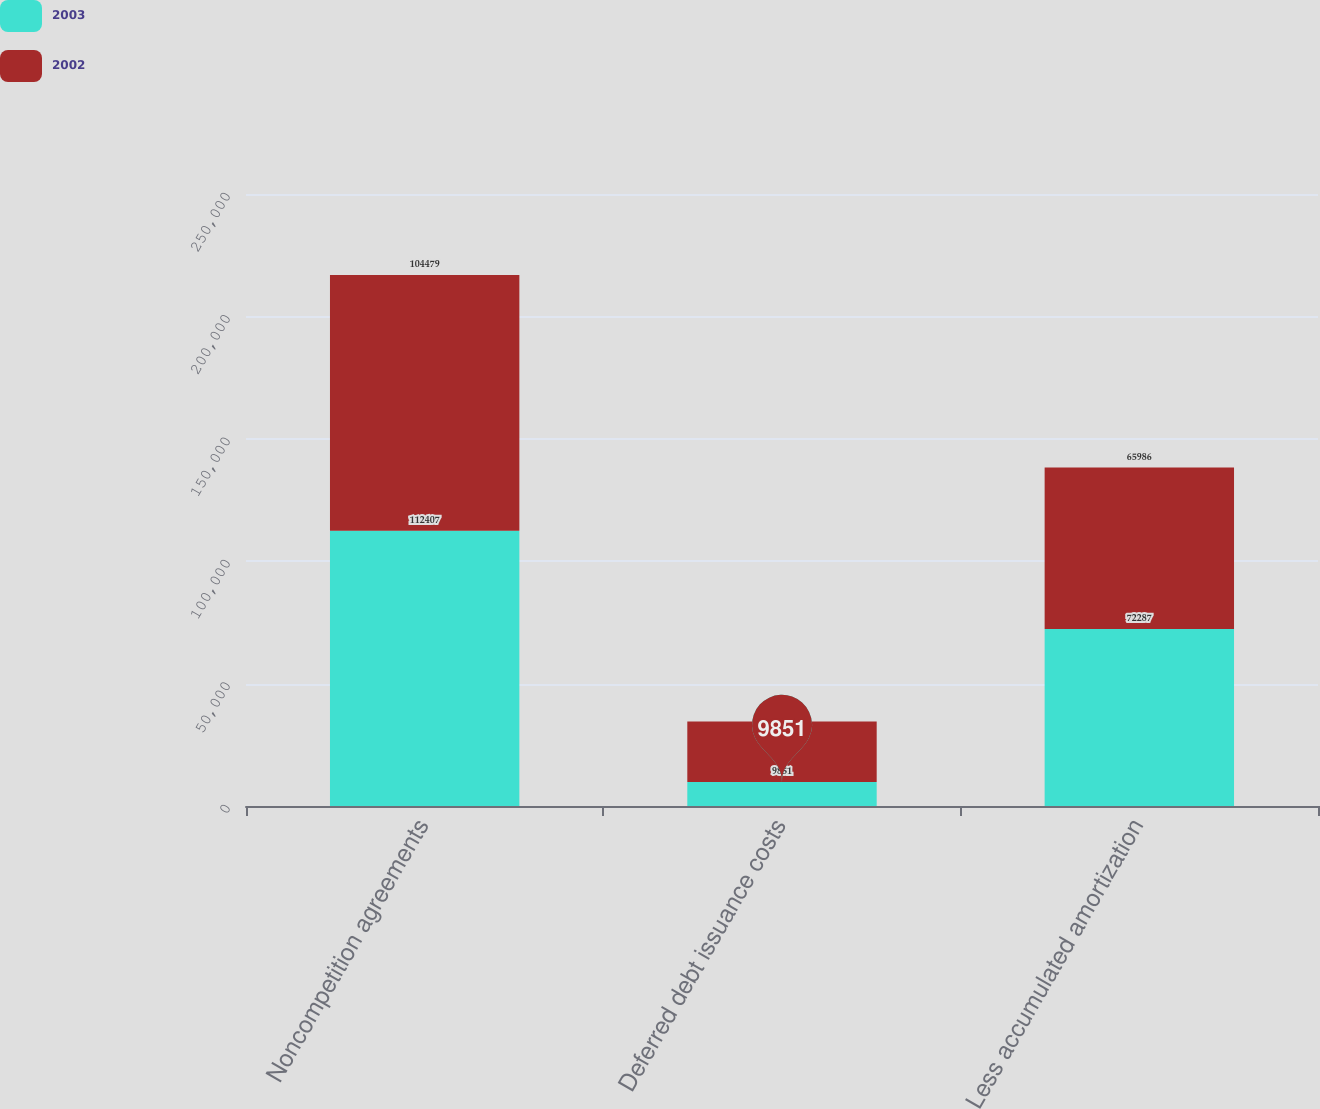Convert chart to OTSL. <chart><loc_0><loc_0><loc_500><loc_500><stacked_bar_chart><ecel><fcel>Noncompetition agreements<fcel>Deferred debt issuance costs<fcel>Less accumulated amortization<nl><fcel>2003<fcel>112407<fcel>9851<fcel>72287<nl><fcel>2002<fcel>104479<fcel>24666<fcel>65986<nl></chart> 